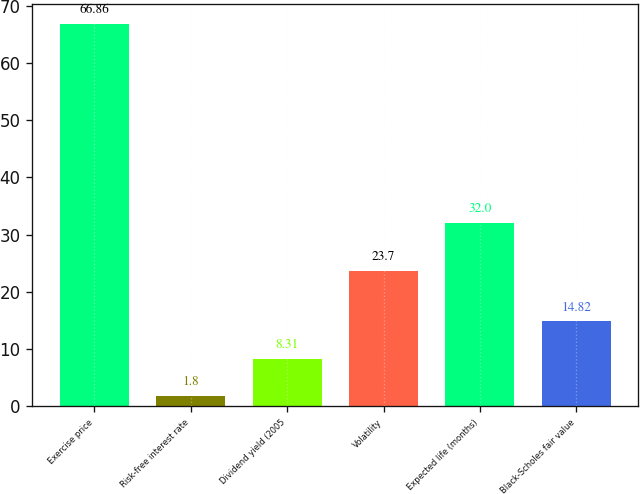<chart> <loc_0><loc_0><loc_500><loc_500><bar_chart><fcel>Exercise price<fcel>Risk-free interest rate<fcel>Dividend yield (2005<fcel>Volatility<fcel>Expected life (months)<fcel>Black-Scholes fair value<nl><fcel>66.86<fcel>1.8<fcel>8.31<fcel>23.7<fcel>32<fcel>14.82<nl></chart> 